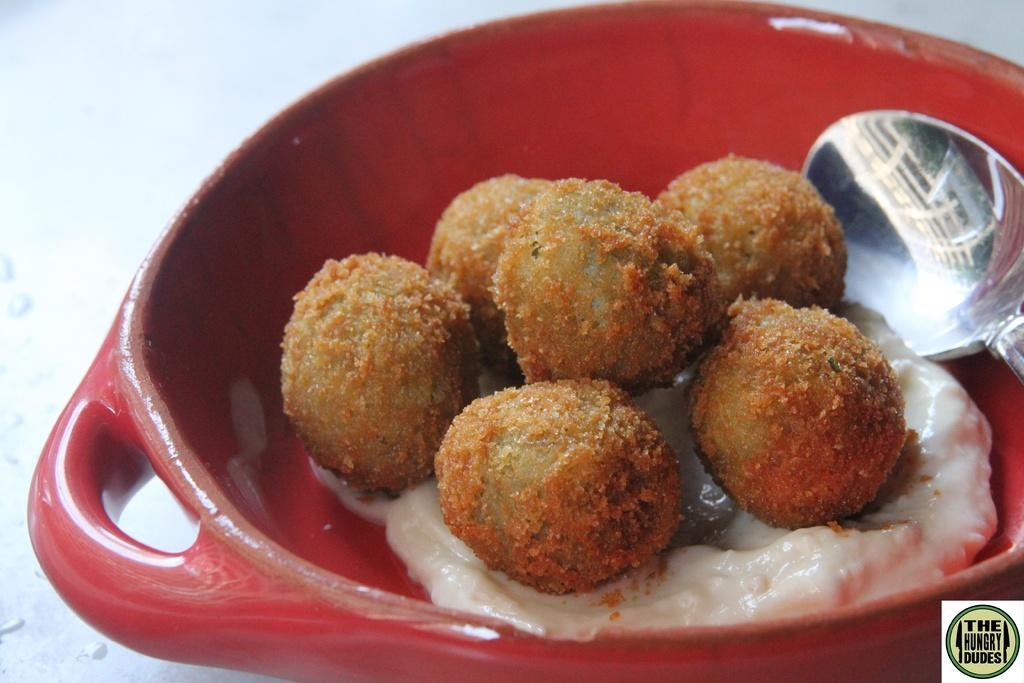How would you summarize this image in a sentence or two? In the center of the image we can see a bowl of food item with spoon are there. 